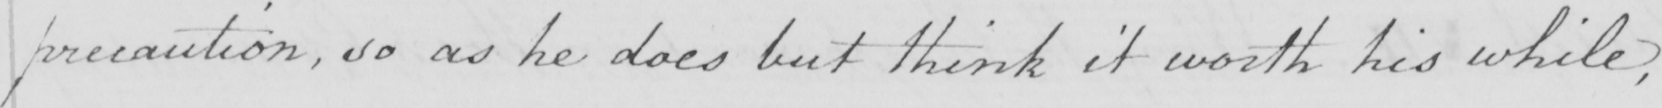What text is written in this handwritten line? precaution , so as he does but think it worth his while , 